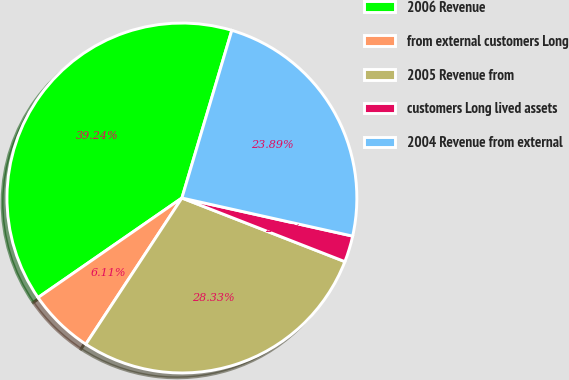Convert chart. <chart><loc_0><loc_0><loc_500><loc_500><pie_chart><fcel>2006 Revenue<fcel>from external customers Long<fcel>2005 Revenue from<fcel>customers Long lived assets<fcel>2004 Revenue from external<nl><fcel>39.24%<fcel>6.11%<fcel>28.33%<fcel>2.43%<fcel>23.89%<nl></chart> 